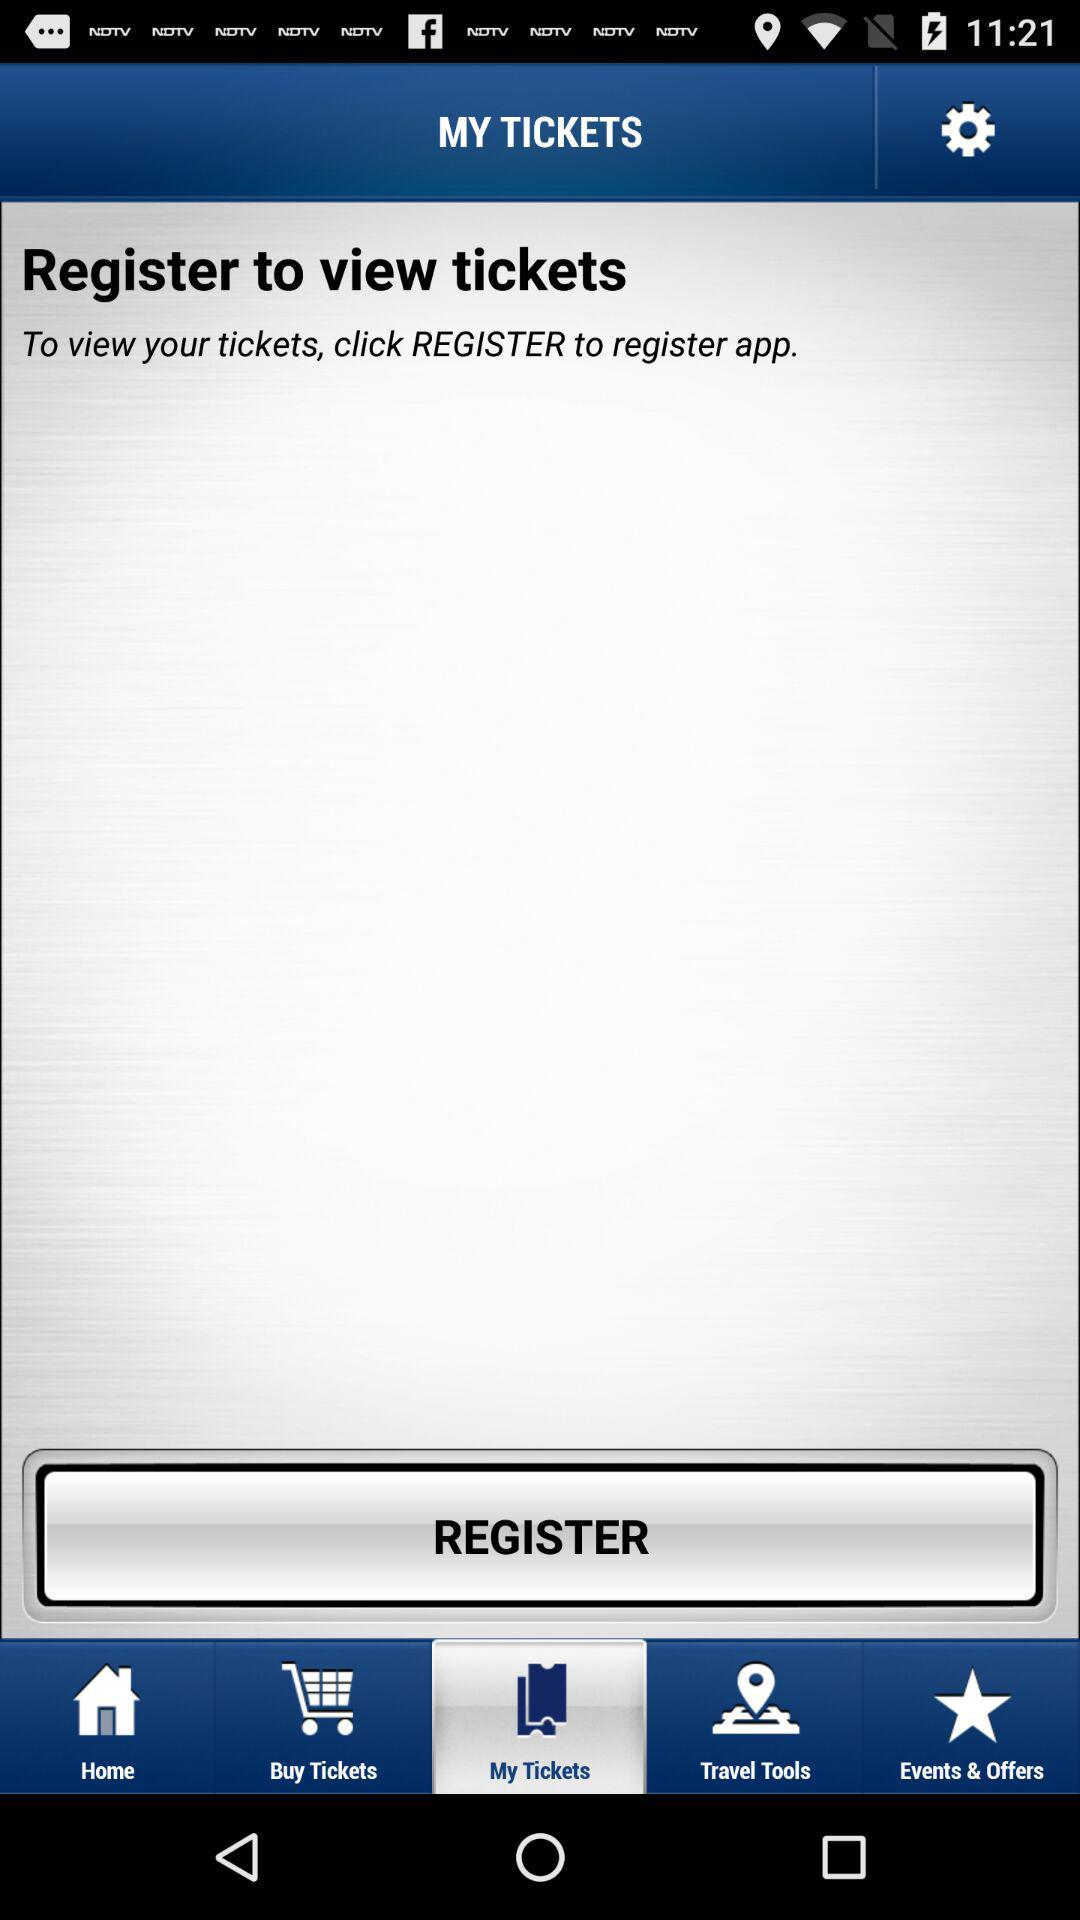What tab is selected?
Answer the question using a single word or phrase. The selected tab is "My Tickets".c 